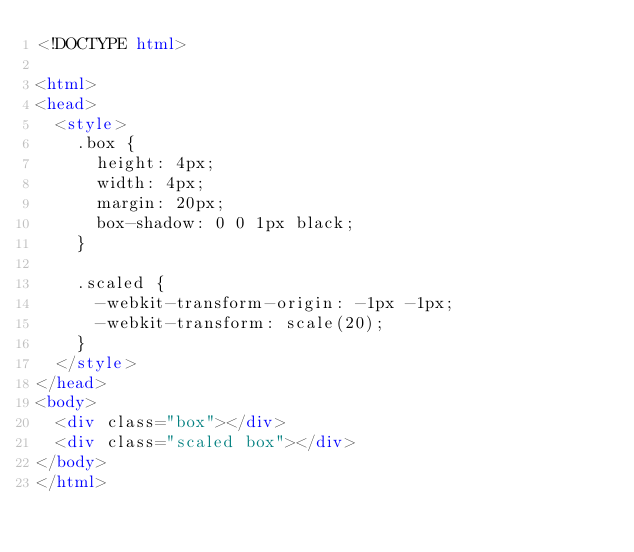Convert code to text. <code><loc_0><loc_0><loc_500><loc_500><_HTML_><!DOCTYPE html>

<html>
<head>
  <style>
    .box {
      height: 4px;
      width: 4px;
      margin: 20px;
      box-shadow: 0 0 1px black;
    }
    
    .scaled {
      -webkit-transform-origin: -1px -1px;
      -webkit-transform: scale(20);
    }
  </style>
</head>
<body>
  <div class="box"></div>
  <div class="scaled box"></div>
</body>
</html>
</code> 